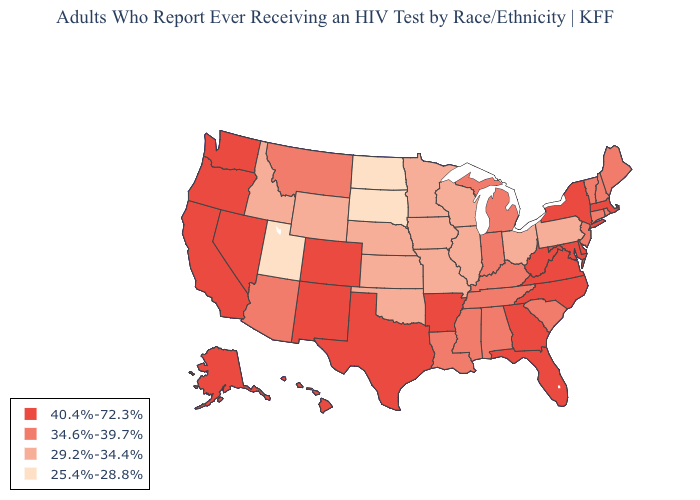What is the highest value in the South ?
Write a very short answer. 40.4%-72.3%. Name the states that have a value in the range 25.4%-28.8%?
Concise answer only. North Dakota, South Dakota, Utah. Which states hav the highest value in the South?
Short answer required. Arkansas, Delaware, Florida, Georgia, Maryland, North Carolina, Texas, Virginia, West Virginia. Name the states that have a value in the range 40.4%-72.3%?
Quick response, please. Alaska, Arkansas, California, Colorado, Delaware, Florida, Georgia, Hawaii, Maryland, Massachusetts, Nevada, New Mexico, New York, North Carolina, Oregon, Texas, Virginia, Washington, West Virginia. Among the states that border New York , does Connecticut have the lowest value?
Be succinct. No. What is the lowest value in states that border New Jersey?
Be succinct. 29.2%-34.4%. What is the highest value in states that border California?
Answer briefly. 40.4%-72.3%. Name the states that have a value in the range 34.6%-39.7%?
Short answer required. Alabama, Arizona, Connecticut, Indiana, Kentucky, Louisiana, Maine, Michigan, Mississippi, Montana, New Hampshire, New Jersey, Rhode Island, South Carolina, Tennessee, Vermont. What is the value of Delaware?
Concise answer only. 40.4%-72.3%. Which states have the lowest value in the USA?
Be succinct. North Dakota, South Dakota, Utah. Does Tennessee have a higher value than Wyoming?
Concise answer only. Yes. Which states have the highest value in the USA?
Be succinct. Alaska, Arkansas, California, Colorado, Delaware, Florida, Georgia, Hawaii, Maryland, Massachusetts, Nevada, New Mexico, New York, North Carolina, Oregon, Texas, Virginia, Washington, West Virginia. Among the states that border Oregon , which have the lowest value?
Concise answer only. Idaho. Among the states that border Virginia , which have the lowest value?
Quick response, please. Kentucky, Tennessee. What is the value of Massachusetts?
Be succinct. 40.4%-72.3%. 